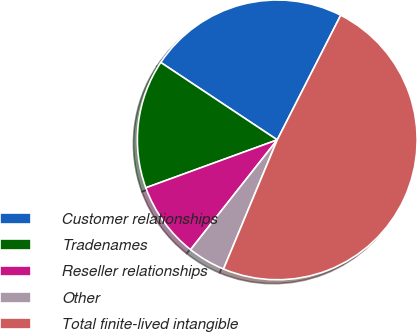<chart> <loc_0><loc_0><loc_500><loc_500><pie_chart><fcel>Customer relationships<fcel>Tradenames<fcel>Reseller relationships<fcel>Other<fcel>Total finite-lived intangible<nl><fcel>23.16%<fcel>14.9%<fcel>8.8%<fcel>4.36%<fcel>48.78%<nl></chart> 